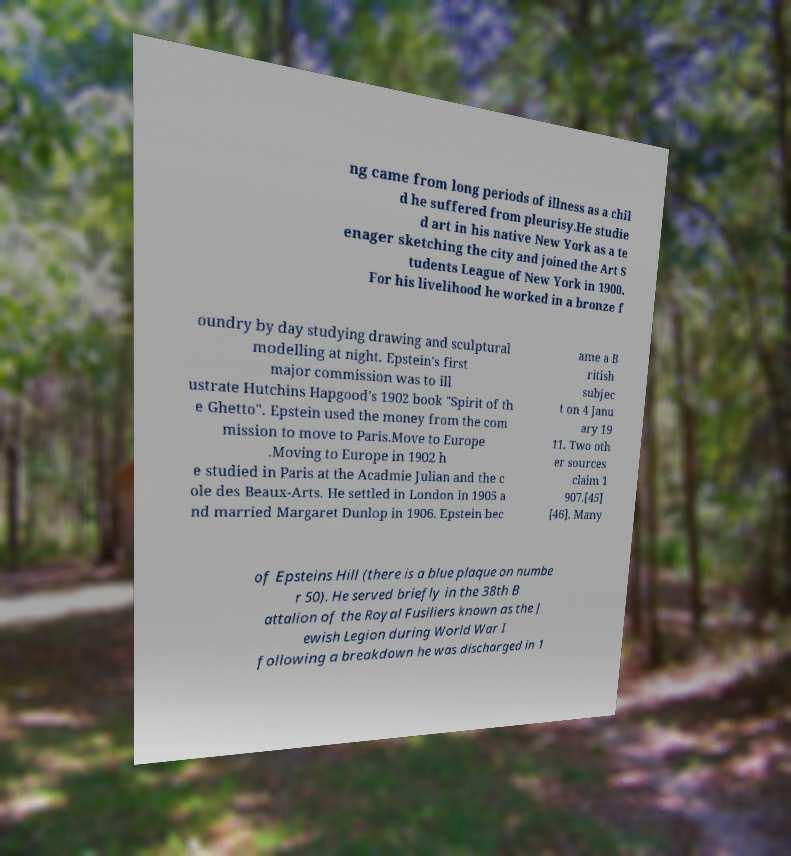Can you read and provide the text displayed in the image?This photo seems to have some interesting text. Can you extract and type it out for me? ng came from long periods of illness as a chil d he suffered from pleurisy.He studie d art in his native New York as a te enager sketching the city and joined the Art S tudents League of New York in 1900. For his livelihood he worked in a bronze f oundry by day studying drawing and sculptural modelling at night. Epstein's first major commission was to ill ustrate Hutchins Hapgood's 1902 book "Spirit of th e Ghetto". Epstein used the money from the com mission to move to Paris.Move to Europe .Moving to Europe in 1902 h e studied in Paris at the Acadmie Julian and the c ole des Beaux-Arts. He settled in London in 1905 a nd married Margaret Dunlop in 1906. Epstein bec ame a B ritish subjec t on 4 Janu ary 19 11. Two oth er sources claim 1 907.[45] [46]. Many of Epsteins Hill (there is a blue plaque on numbe r 50). He served briefly in the 38th B attalion of the Royal Fusiliers known as the J ewish Legion during World War I following a breakdown he was discharged in 1 